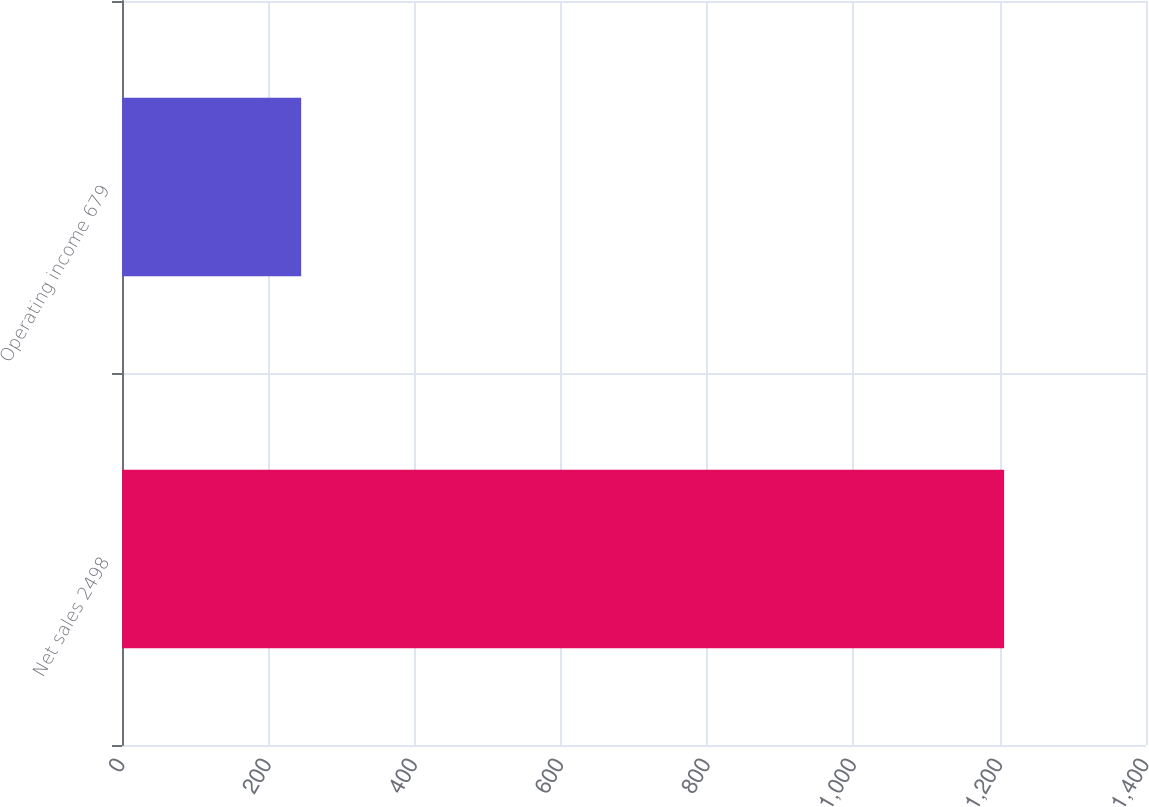<chart> <loc_0><loc_0><loc_500><loc_500><bar_chart><fcel>Net sales 2498<fcel>Operating income 679<nl><fcel>1206<fcel>245<nl></chart> 